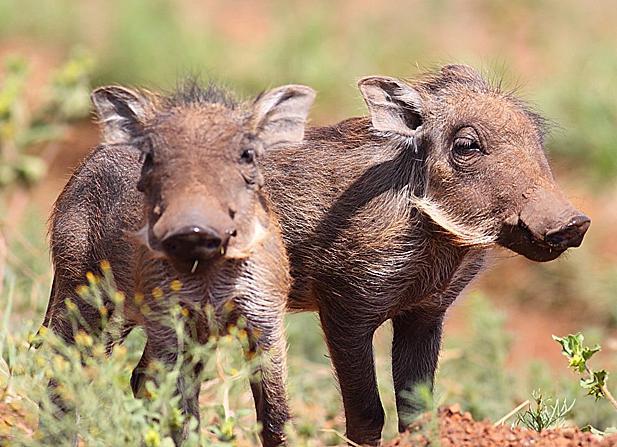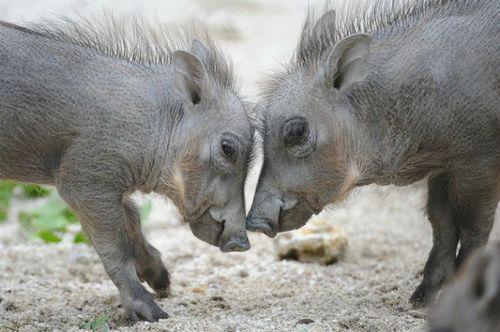The first image is the image on the left, the second image is the image on the right. Examine the images to the left and right. Is the description "One of the animals is lying down on the ground." accurate? Answer yes or no. No. The first image is the image on the left, the second image is the image on the right. Given the left and right images, does the statement "Left and right images contain the same number of warthogs, and the combined images contain at least four warthogs." hold true? Answer yes or no. Yes. 